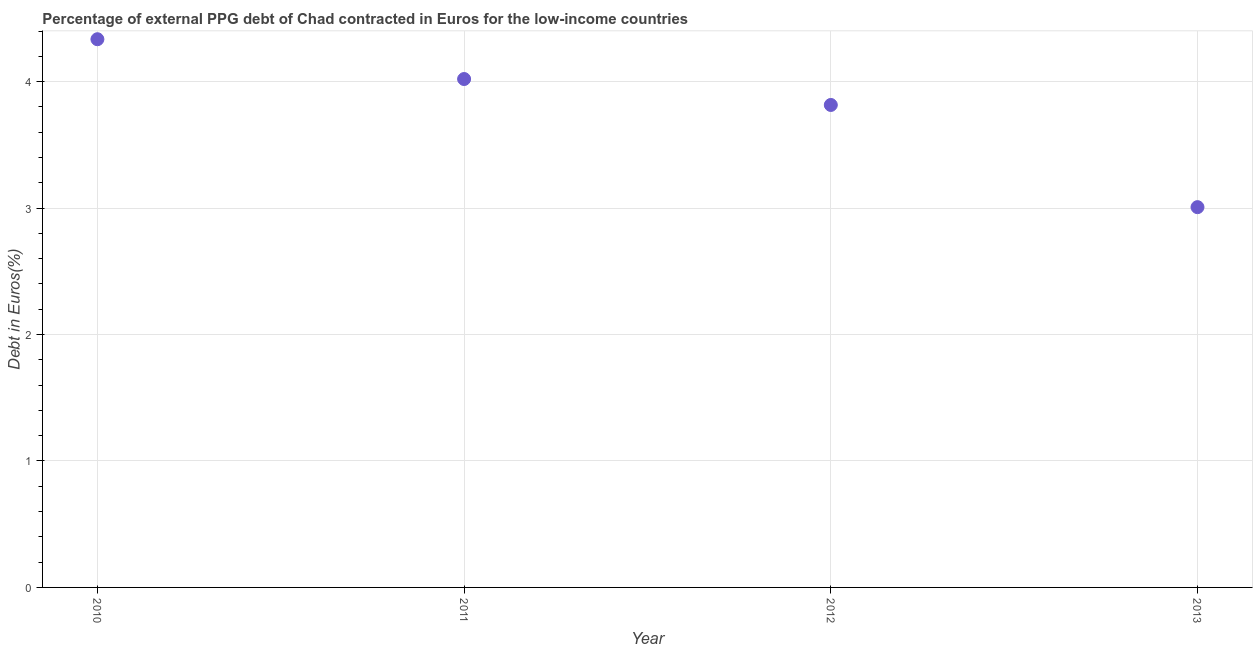What is the currency composition of ppg debt in 2010?
Provide a short and direct response. 4.34. Across all years, what is the maximum currency composition of ppg debt?
Your response must be concise. 4.34. Across all years, what is the minimum currency composition of ppg debt?
Provide a short and direct response. 3.01. What is the sum of the currency composition of ppg debt?
Ensure brevity in your answer.  15.18. What is the difference between the currency composition of ppg debt in 2012 and 2013?
Offer a very short reply. 0.81. What is the average currency composition of ppg debt per year?
Ensure brevity in your answer.  3.79. What is the median currency composition of ppg debt?
Offer a very short reply. 3.92. In how many years, is the currency composition of ppg debt greater than 1 %?
Keep it short and to the point. 4. Do a majority of the years between 2013 and 2012 (inclusive) have currency composition of ppg debt greater than 0.4 %?
Provide a short and direct response. No. What is the ratio of the currency composition of ppg debt in 2010 to that in 2013?
Your answer should be very brief. 1.44. Is the currency composition of ppg debt in 2010 less than that in 2013?
Provide a succinct answer. No. What is the difference between the highest and the second highest currency composition of ppg debt?
Give a very brief answer. 0.31. Is the sum of the currency composition of ppg debt in 2011 and 2013 greater than the maximum currency composition of ppg debt across all years?
Give a very brief answer. Yes. What is the difference between the highest and the lowest currency composition of ppg debt?
Offer a terse response. 1.33. In how many years, is the currency composition of ppg debt greater than the average currency composition of ppg debt taken over all years?
Provide a short and direct response. 3. Does the currency composition of ppg debt monotonically increase over the years?
Offer a very short reply. No. How many dotlines are there?
Ensure brevity in your answer.  1. How many years are there in the graph?
Ensure brevity in your answer.  4. What is the difference between two consecutive major ticks on the Y-axis?
Your response must be concise. 1. Are the values on the major ticks of Y-axis written in scientific E-notation?
Make the answer very short. No. Does the graph contain any zero values?
Provide a short and direct response. No. What is the title of the graph?
Offer a terse response. Percentage of external PPG debt of Chad contracted in Euros for the low-income countries. What is the label or title of the Y-axis?
Provide a succinct answer. Debt in Euros(%). What is the Debt in Euros(%) in 2010?
Offer a terse response. 4.34. What is the Debt in Euros(%) in 2011?
Give a very brief answer. 4.02. What is the Debt in Euros(%) in 2012?
Provide a short and direct response. 3.82. What is the Debt in Euros(%) in 2013?
Your response must be concise. 3.01. What is the difference between the Debt in Euros(%) in 2010 and 2011?
Your answer should be compact. 0.31. What is the difference between the Debt in Euros(%) in 2010 and 2012?
Give a very brief answer. 0.52. What is the difference between the Debt in Euros(%) in 2010 and 2013?
Provide a succinct answer. 1.33. What is the difference between the Debt in Euros(%) in 2011 and 2012?
Your response must be concise. 0.21. What is the difference between the Debt in Euros(%) in 2011 and 2013?
Keep it short and to the point. 1.01. What is the difference between the Debt in Euros(%) in 2012 and 2013?
Ensure brevity in your answer.  0.81. What is the ratio of the Debt in Euros(%) in 2010 to that in 2011?
Give a very brief answer. 1.08. What is the ratio of the Debt in Euros(%) in 2010 to that in 2012?
Your response must be concise. 1.14. What is the ratio of the Debt in Euros(%) in 2010 to that in 2013?
Offer a terse response. 1.44. What is the ratio of the Debt in Euros(%) in 2011 to that in 2012?
Give a very brief answer. 1.05. What is the ratio of the Debt in Euros(%) in 2011 to that in 2013?
Offer a very short reply. 1.34. What is the ratio of the Debt in Euros(%) in 2012 to that in 2013?
Ensure brevity in your answer.  1.27. 